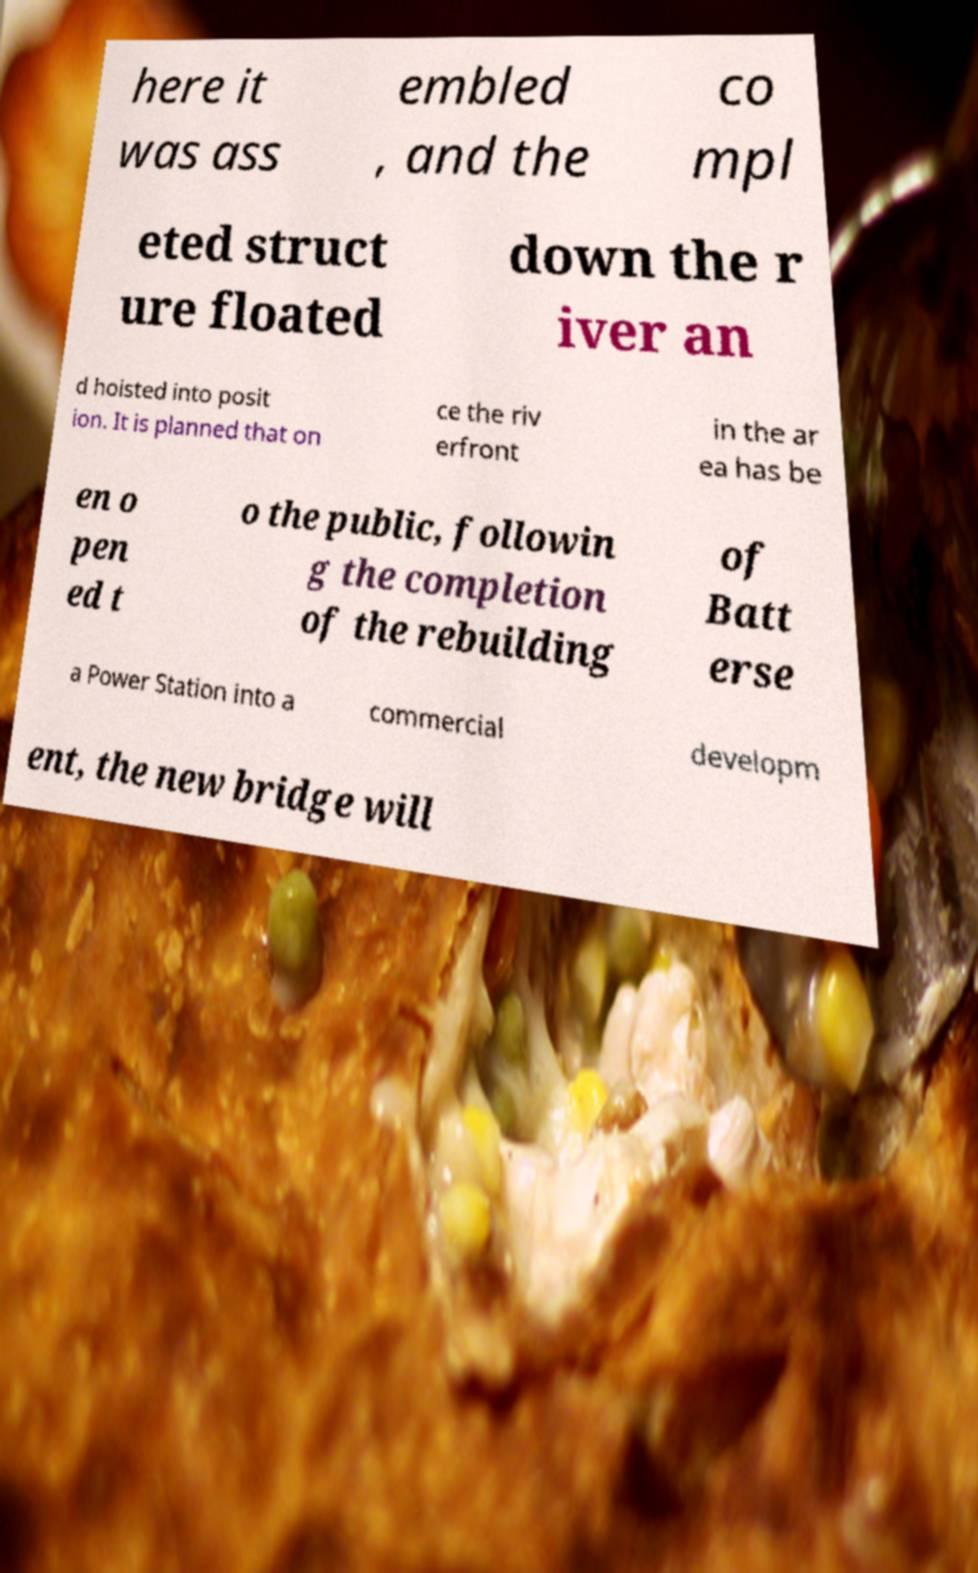There's text embedded in this image that I need extracted. Can you transcribe it verbatim? here it was ass embled , and the co mpl eted struct ure floated down the r iver an d hoisted into posit ion. It is planned that on ce the riv erfront in the ar ea has be en o pen ed t o the public, followin g the completion of the rebuilding of Batt erse a Power Station into a commercial developm ent, the new bridge will 